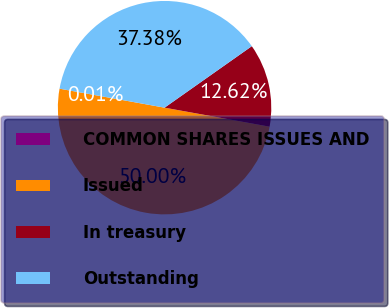<chart> <loc_0><loc_0><loc_500><loc_500><pie_chart><fcel>COMMON SHARES ISSUES AND<fcel>Issued<fcel>In treasury<fcel>Outstanding<nl><fcel>0.01%<fcel>50.0%<fcel>12.62%<fcel>37.38%<nl></chart> 